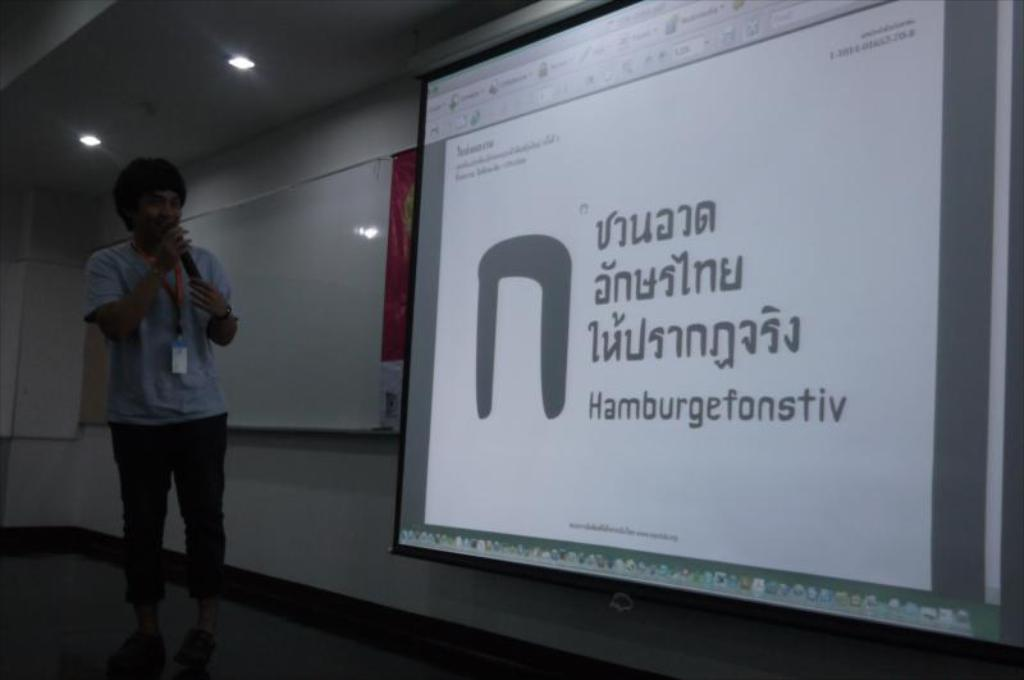What is the man in the image doing? The man is standing in the image and speaking into a microphone. What can be seen on the right side of the image? There is a screen on the right side of the image. What is present on the ceiling in the image? Lights are attached to the ceiling in the image. How many servants are attending to the man in the image? There is no mention of servants in the image; it only shows a man speaking into a microphone, a screen on the right side, and lights on the ceiling. What type of lamp is present on the left side of the image? There is no lamp present on the left side of the image. 